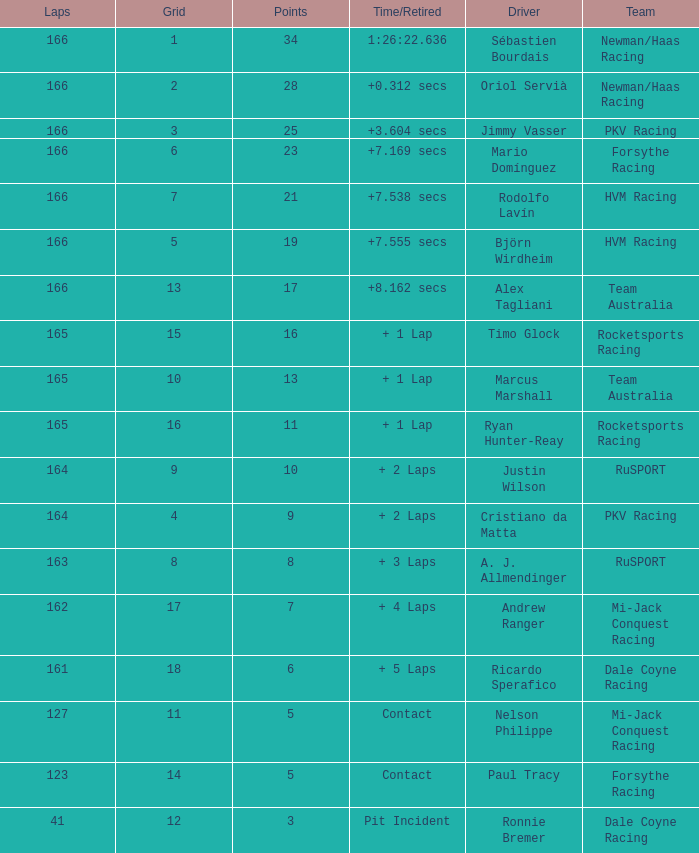Driver Ricardo Sperafico has what as his average laps? 161.0. 